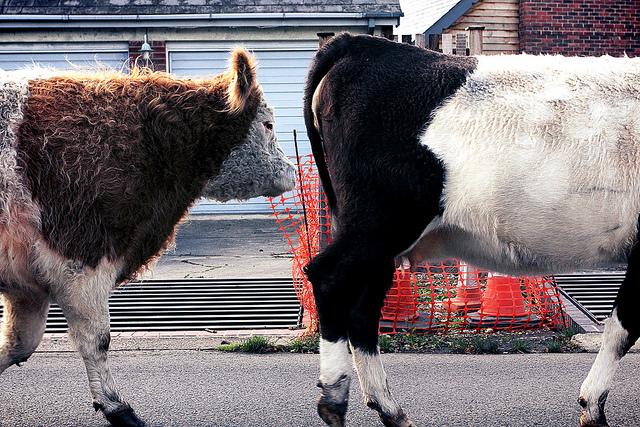Are the cows walking in the same direction or opposite from each other?
Give a very brief answer. Same. Are the cows on a farm?
Be succinct. No. What color are the cows?
Quick response, please. Brown/white & black/white. 